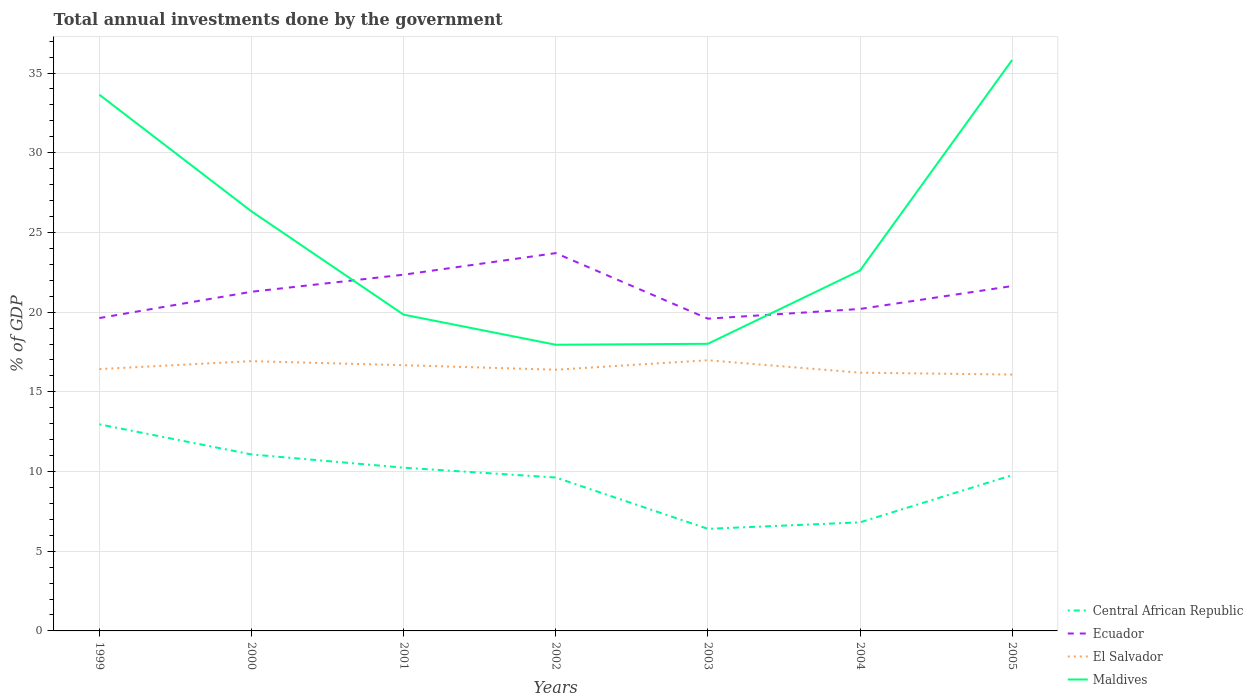Across all years, what is the maximum total annual investments done by the government in Ecuador?
Provide a succinct answer. 19.59. In which year was the total annual investments done by the government in El Salvador maximum?
Your answer should be very brief. 2005. What is the total total annual investments done by the government in Maldives in the graph?
Give a very brief answer. 6.48. What is the difference between the highest and the second highest total annual investments done by the government in Central African Republic?
Your answer should be compact. 6.56. Is the total annual investments done by the government in Ecuador strictly greater than the total annual investments done by the government in Maldives over the years?
Your answer should be compact. No. How many years are there in the graph?
Ensure brevity in your answer.  7. Are the values on the major ticks of Y-axis written in scientific E-notation?
Your answer should be very brief. No. How many legend labels are there?
Keep it short and to the point. 4. What is the title of the graph?
Keep it short and to the point. Total annual investments done by the government. Does "Syrian Arab Republic" appear as one of the legend labels in the graph?
Your answer should be very brief. No. What is the label or title of the X-axis?
Keep it short and to the point. Years. What is the label or title of the Y-axis?
Offer a terse response. % of GDP. What is the % of GDP in Central African Republic in 1999?
Make the answer very short. 12.96. What is the % of GDP in Ecuador in 1999?
Give a very brief answer. 19.63. What is the % of GDP in El Salvador in 1999?
Make the answer very short. 16.43. What is the % of GDP of Maldives in 1999?
Provide a short and direct response. 33.64. What is the % of GDP in Central African Republic in 2000?
Make the answer very short. 11.07. What is the % of GDP of Ecuador in 2000?
Your answer should be compact. 21.28. What is the % of GDP of El Salvador in 2000?
Provide a succinct answer. 16.93. What is the % of GDP of Maldives in 2000?
Make the answer very short. 26.32. What is the % of GDP of Central African Republic in 2001?
Keep it short and to the point. 10.24. What is the % of GDP in Ecuador in 2001?
Make the answer very short. 22.35. What is the % of GDP in El Salvador in 2001?
Offer a very short reply. 16.67. What is the % of GDP of Maldives in 2001?
Keep it short and to the point. 19.84. What is the % of GDP in Central African Republic in 2002?
Provide a succinct answer. 9.62. What is the % of GDP of Ecuador in 2002?
Offer a terse response. 23.7. What is the % of GDP of El Salvador in 2002?
Your response must be concise. 16.39. What is the % of GDP of Maldives in 2002?
Offer a terse response. 17.95. What is the % of GDP of Central African Republic in 2003?
Make the answer very short. 6.4. What is the % of GDP of Ecuador in 2003?
Ensure brevity in your answer.  19.59. What is the % of GDP of El Salvador in 2003?
Provide a succinct answer. 16.98. What is the % of GDP of Maldives in 2003?
Ensure brevity in your answer.  18.01. What is the % of GDP of Central African Republic in 2004?
Make the answer very short. 6.81. What is the % of GDP of Ecuador in 2004?
Give a very brief answer. 20.2. What is the % of GDP of El Salvador in 2004?
Offer a terse response. 16.2. What is the % of GDP of Maldives in 2004?
Your answer should be very brief. 22.61. What is the % of GDP of Central African Republic in 2005?
Offer a very short reply. 9.77. What is the % of GDP in Ecuador in 2005?
Keep it short and to the point. 21.64. What is the % of GDP in El Salvador in 2005?
Offer a terse response. 16.08. What is the % of GDP in Maldives in 2005?
Your answer should be compact. 35.82. Across all years, what is the maximum % of GDP of Central African Republic?
Provide a succinct answer. 12.96. Across all years, what is the maximum % of GDP of Ecuador?
Offer a very short reply. 23.7. Across all years, what is the maximum % of GDP of El Salvador?
Make the answer very short. 16.98. Across all years, what is the maximum % of GDP in Maldives?
Your answer should be compact. 35.82. Across all years, what is the minimum % of GDP of Central African Republic?
Your answer should be very brief. 6.4. Across all years, what is the minimum % of GDP in Ecuador?
Your answer should be very brief. 19.59. Across all years, what is the minimum % of GDP of El Salvador?
Keep it short and to the point. 16.08. Across all years, what is the minimum % of GDP of Maldives?
Provide a succinct answer. 17.95. What is the total % of GDP of Central African Republic in the graph?
Provide a short and direct response. 66.89. What is the total % of GDP of Ecuador in the graph?
Provide a short and direct response. 148.38. What is the total % of GDP in El Salvador in the graph?
Provide a short and direct response. 115.68. What is the total % of GDP of Maldives in the graph?
Give a very brief answer. 174.2. What is the difference between the % of GDP of Central African Republic in 1999 and that in 2000?
Offer a very short reply. 1.89. What is the difference between the % of GDP in Ecuador in 1999 and that in 2000?
Keep it short and to the point. -1.65. What is the difference between the % of GDP in El Salvador in 1999 and that in 2000?
Ensure brevity in your answer.  -0.5. What is the difference between the % of GDP in Maldives in 1999 and that in 2000?
Provide a short and direct response. 7.32. What is the difference between the % of GDP of Central African Republic in 1999 and that in 2001?
Make the answer very short. 2.72. What is the difference between the % of GDP of Ecuador in 1999 and that in 2001?
Offer a terse response. -2.72. What is the difference between the % of GDP in El Salvador in 1999 and that in 2001?
Provide a succinct answer. -0.24. What is the difference between the % of GDP in Maldives in 1999 and that in 2001?
Your answer should be very brief. 13.8. What is the difference between the % of GDP in Central African Republic in 1999 and that in 2002?
Provide a succinct answer. 3.34. What is the difference between the % of GDP in Ecuador in 1999 and that in 2002?
Provide a succinct answer. -4.07. What is the difference between the % of GDP in El Salvador in 1999 and that in 2002?
Keep it short and to the point. 0.04. What is the difference between the % of GDP in Maldives in 1999 and that in 2002?
Offer a very short reply. 15.68. What is the difference between the % of GDP of Central African Republic in 1999 and that in 2003?
Provide a short and direct response. 6.56. What is the difference between the % of GDP of Ecuador in 1999 and that in 2003?
Give a very brief answer. 0.04. What is the difference between the % of GDP in El Salvador in 1999 and that in 2003?
Provide a succinct answer. -0.55. What is the difference between the % of GDP in Maldives in 1999 and that in 2003?
Your response must be concise. 15.63. What is the difference between the % of GDP of Central African Republic in 1999 and that in 2004?
Your answer should be very brief. 6.15. What is the difference between the % of GDP of Ecuador in 1999 and that in 2004?
Give a very brief answer. -0.57. What is the difference between the % of GDP of El Salvador in 1999 and that in 2004?
Offer a very short reply. 0.22. What is the difference between the % of GDP of Maldives in 1999 and that in 2004?
Offer a terse response. 11.03. What is the difference between the % of GDP in Central African Republic in 1999 and that in 2005?
Provide a short and direct response. 3.19. What is the difference between the % of GDP in Ecuador in 1999 and that in 2005?
Make the answer very short. -2.01. What is the difference between the % of GDP of El Salvador in 1999 and that in 2005?
Provide a short and direct response. 0.34. What is the difference between the % of GDP in Maldives in 1999 and that in 2005?
Provide a succinct answer. -2.18. What is the difference between the % of GDP of Central African Republic in 2000 and that in 2001?
Make the answer very short. 0.83. What is the difference between the % of GDP of Ecuador in 2000 and that in 2001?
Ensure brevity in your answer.  -1.07. What is the difference between the % of GDP of El Salvador in 2000 and that in 2001?
Keep it short and to the point. 0.26. What is the difference between the % of GDP in Maldives in 2000 and that in 2001?
Keep it short and to the point. 6.48. What is the difference between the % of GDP of Central African Republic in 2000 and that in 2002?
Make the answer very short. 1.45. What is the difference between the % of GDP in Ecuador in 2000 and that in 2002?
Provide a succinct answer. -2.42. What is the difference between the % of GDP in El Salvador in 2000 and that in 2002?
Offer a terse response. 0.54. What is the difference between the % of GDP in Maldives in 2000 and that in 2002?
Your response must be concise. 8.37. What is the difference between the % of GDP in Central African Republic in 2000 and that in 2003?
Your answer should be very brief. 4.67. What is the difference between the % of GDP in Ecuador in 2000 and that in 2003?
Ensure brevity in your answer.  1.69. What is the difference between the % of GDP in El Salvador in 2000 and that in 2003?
Keep it short and to the point. -0.06. What is the difference between the % of GDP of Maldives in 2000 and that in 2003?
Offer a terse response. 8.31. What is the difference between the % of GDP in Central African Republic in 2000 and that in 2004?
Provide a succinct answer. 4.26. What is the difference between the % of GDP of Ecuador in 2000 and that in 2004?
Give a very brief answer. 1.08. What is the difference between the % of GDP in El Salvador in 2000 and that in 2004?
Offer a very short reply. 0.72. What is the difference between the % of GDP of Maldives in 2000 and that in 2004?
Keep it short and to the point. 3.71. What is the difference between the % of GDP in Central African Republic in 2000 and that in 2005?
Make the answer very short. 1.3. What is the difference between the % of GDP of Ecuador in 2000 and that in 2005?
Ensure brevity in your answer.  -0.36. What is the difference between the % of GDP of El Salvador in 2000 and that in 2005?
Offer a very short reply. 0.84. What is the difference between the % of GDP in Maldives in 2000 and that in 2005?
Keep it short and to the point. -9.49. What is the difference between the % of GDP in Central African Republic in 2001 and that in 2002?
Keep it short and to the point. 0.62. What is the difference between the % of GDP in Ecuador in 2001 and that in 2002?
Ensure brevity in your answer.  -1.35. What is the difference between the % of GDP of El Salvador in 2001 and that in 2002?
Offer a very short reply. 0.28. What is the difference between the % of GDP of Maldives in 2001 and that in 2002?
Provide a short and direct response. 1.89. What is the difference between the % of GDP of Central African Republic in 2001 and that in 2003?
Your answer should be very brief. 3.84. What is the difference between the % of GDP in Ecuador in 2001 and that in 2003?
Make the answer very short. 2.76. What is the difference between the % of GDP of El Salvador in 2001 and that in 2003?
Provide a succinct answer. -0.31. What is the difference between the % of GDP of Maldives in 2001 and that in 2003?
Provide a short and direct response. 1.83. What is the difference between the % of GDP of Central African Republic in 2001 and that in 2004?
Offer a very short reply. 3.43. What is the difference between the % of GDP of Ecuador in 2001 and that in 2004?
Provide a short and direct response. 2.15. What is the difference between the % of GDP of El Salvador in 2001 and that in 2004?
Your response must be concise. 0.47. What is the difference between the % of GDP of Maldives in 2001 and that in 2004?
Your response must be concise. -2.77. What is the difference between the % of GDP in Central African Republic in 2001 and that in 2005?
Give a very brief answer. 0.47. What is the difference between the % of GDP in Ecuador in 2001 and that in 2005?
Offer a very short reply. 0.71. What is the difference between the % of GDP of El Salvador in 2001 and that in 2005?
Offer a very short reply. 0.59. What is the difference between the % of GDP of Maldives in 2001 and that in 2005?
Provide a short and direct response. -15.97. What is the difference between the % of GDP in Central African Republic in 2002 and that in 2003?
Make the answer very short. 3.22. What is the difference between the % of GDP of Ecuador in 2002 and that in 2003?
Give a very brief answer. 4.11. What is the difference between the % of GDP of El Salvador in 2002 and that in 2003?
Offer a terse response. -0.59. What is the difference between the % of GDP in Maldives in 2002 and that in 2003?
Your answer should be very brief. -0.06. What is the difference between the % of GDP in Central African Republic in 2002 and that in 2004?
Offer a very short reply. 2.81. What is the difference between the % of GDP of Ecuador in 2002 and that in 2004?
Offer a terse response. 3.5. What is the difference between the % of GDP in El Salvador in 2002 and that in 2004?
Your response must be concise. 0.19. What is the difference between the % of GDP in Maldives in 2002 and that in 2004?
Keep it short and to the point. -4.66. What is the difference between the % of GDP in Central African Republic in 2002 and that in 2005?
Keep it short and to the point. -0.15. What is the difference between the % of GDP in Ecuador in 2002 and that in 2005?
Your answer should be very brief. 2.07. What is the difference between the % of GDP in El Salvador in 2002 and that in 2005?
Give a very brief answer. 0.3. What is the difference between the % of GDP in Maldives in 2002 and that in 2005?
Your answer should be very brief. -17.86. What is the difference between the % of GDP of Central African Republic in 2003 and that in 2004?
Provide a short and direct response. -0.41. What is the difference between the % of GDP of Ecuador in 2003 and that in 2004?
Offer a terse response. -0.61. What is the difference between the % of GDP of El Salvador in 2003 and that in 2004?
Make the answer very short. 0.78. What is the difference between the % of GDP of Maldives in 2003 and that in 2004?
Your answer should be compact. -4.6. What is the difference between the % of GDP of Central African Republic in 2003 and that in 2005?
Provide a succinct answer. -3.37. What is the difference between the % of GDP of Ecuador in 2003 and that in 2005?
Offer a terse response. -2.05. What is the difference between the % of GDP in El Salvador in 2003 and that in 2005?
Ensure brevity in your answer.  0.9. What is the difference between the % of GDP in Maldives in 2003 and that in 2005?
Offer a very short reply. -17.8. What is the difference between the % of GDP of Central African Republic in 2004 and that in 2005?
Provide a short and direct response. -2.96. What is the difference between the % of GDP in Ecuador in 2004 and that in 2005?
Your answer should be very brief. -1.44. What is the difference between the % of GDP of El Salvador in 2004 and that in 2005?
Your response must be concise. 0.12. What is the difference between the % of GDP of Maldives in 2004 and that in 2005?
Keep it short and to the point. -13.21. What is the difference between the % of GDP of Central African Republic in 1999 and the % of GDP of Ecuador in 2000?
Provide a succinct answer. -8.32. What is the difference between the % of GDP in Central African Republic in 1999 and the % of GDP in El Salvador in 2000?
Offer a terse response. -3.96. What is the difference between the % of GDP of Central African Republic in 1999 and the % of GDP of Maldives in 2000?
Offer a terse response. -13.36. What is the difference between the % of GDP in Ecuador in 1999 and the % of GDP in El Salvador in 2000?
Keep it short and to the point. 2.7. What is the difference between the % of GDP of Ecuador in 1999 and the % of GDP of Maldives in 2000?
Provide a succinct answer. -6.69. What is the difference between the % of GDP in El Salvador in 1999 and the % of GDP in Maldives in 2000?
Provide a succinct answer. -9.9. What is the difference between the % of GDP of Central African Republic in 1999 and the % of GDP of Ecuador in 2001?
Ensure brevity in your answer.  -9.39. What is the difference between the % of GDP in Central African Republic in 1999 and the % of GDP in El Salvador in 2001?
Provide a short and direct response. -3.71. What is the difference between the % of GDP of Central African Republic in 1999 and the % of GDP of Maldives in 2001?
Your answer should be compact. -6.88. What is the difference between the % of GDP in Ecuador in 1999 and the % of GDP in El Salvador in 2001?
Provide a short and direct response. 2.96. What is the difference between the % of GDP of Ecuador in 1999 and the % of GDP of Maldives in 2001?
Keep it short and to the point. -0.21. What is the difference between the % of GDP in El Salvador in 1999 and the % of GDP in Maldives in 2001?
Ensure brevity in your answer.  -3.42. What is the difference between the % of GDP of Central African Republic in 1999 and the % of GDP of Ecuador in 2002?
Keep it short and to the point. -10.74. What is the difference between the % of GDP of Central African Republic in 1999 and the % of GDP of El Salvador in 2002?
Make the answer very short. -3.43. What is the difference between the % of GDP in Central African Republic in 1999 and the % of GDP in Maldives in 2002?
Give a very brief answer. -4.99. What is the difference between the % of GDP of Ecuador in 1999 and the % of GDP of El Salvador in 2002?
Ensure brevity in your answer.  3.24. What is the difference between the % of GDP in Ecuador in 1999 and the % of GDP in Maldives in 2002?
Ensure brevity in your answer.  1.67. What is the difference between the % of GDP in El Salvador in 1999 and the % of GDP in Maldives in 2002?
Provide a short and direct response. -1.53. What is the difference between the % of GDP in Central African Republic in 1999 and the % of GDP in Ecuador in 2003?
Keep it short and to the point. -6.63. What is the difference between the % of GDP of Central African Republic in 1999 and the % of GDP of El Salvador in 2003?
Provide a succinct answer. -4.02. What is the difference between the % of GDP of Central African Republic in 1999 and the % of GDP of Maldives in 2003?
Offer a terse response. -5.05. What is the difference between the % of GDP in Ecuador in 1999 and the % of GDP in El Salvador in 2003?
Give a very brief answer. 2.65. What is the difference between the % of GDP of Ecuador in 1999 and the % of GDP of Maldives in 2003?
Offer a terse response. 1.61. What is the difference between the % of GDP in El Salvador in 1999 and the % of GDP in Maldives in 2003?
Your answer should be very brief. -1.59. What is the difference between the % of GDP of Central African Republic in 1999 and the % of GDP of Ecuador in 2004?
Your answer should be very brief. -7.24. What is the difference between the % of GDP of Central African Republic in 1999 and the % of GDP of El Salvador in 2004?
Give a very brief answer. -3.24. What is the difference between the % of GDP of Central African Republic in 1999 and the % of GDP of Maldives in 2004?
Offer a terse response. -9.65. What is the difference between the % of GDP in Ecuador in 1999 and the % of GDP in El Salvador in 2004?
Your answer should be compact. 3.43. What is the difference between the % of GDP of Ecuador in 1999 and the % of GDP of Maldives in 2004?
Your response must be concise. -2.98. What is the difference between the % of GDP in El Salvador in 1999 and the % of GDP in Maldives in 2004?
Offer a very short reply. -6.18. What is the difference between the % of GDP in Central African Republic in 1999 and the % of GDP in Ecuador in 2005?
Offer a terse response. -8.68. What is the difference between the % of GDP of Central African Republic in 1999 and the % of GDP of El Salvador in 2005?
Keep it short and to the point. -3.12. What is the difference between the % of GDP of Central African Republic in 1999 and the % of GDP of Maldives in 2005?
Provide a succinct answer. -22.86. What is the difference between the % of GDP in Ecuador in 1999 and the % of GDP in El Salvador in 2005?
Your answer should be very brief. 3.55. What is the difference between the % of GDP of Ecuador in 1999 and the % of GDP of Maldives in 2005?
Keep it short and to the point. -16.19. What is the difference between the % of GDP of El Salvador in 1999 and the % of GDP of Maldives in 2005?
Ensure brevity in your answer.  -19.39. What is the difference between the % of GDP of Central African Republic in 2000 and the % of GDP of Ecuador in 2001?
Offer a very short reply. -11.28. What is the difference between the % of GDP in Central African Republic in 2000 and the % of GDP in El Salvador in 2001?
Keep it short and to the point. -5.6. What is the difference between the % of GDP of Central African Republic in 2000 and the % of GDP of Maldives in 2001?
Give a very brief answer. -8.77. What is the difference between the % of GDP in Ecuador in 2000 and the % of GDP in El Salvador in 2001?
Give a very brief answer. 4.61. What is the difference between the % of GDP of Ecuador in 2000 and the % of GDP of Maldives in 2001?
Keep it short and to the point. 1.44. What is the difference between the % of GDP in El Salvador in 2000 and the % of GDP in Maldives in 2001?
Your answer should be compact. -2.92. What is the difference between the % of GDP of Central African Republic in 2000 and the % of GDP of Ecuador in 2002?
Your answer should be compact. -12.63. What is the difference between the % of GDP of Central African Republic in 2000 and the % of GDP of El Salvador in 2002?
Your response must be concise. -5.32. What is the difference between the % of GDP in Central African Republic in 2000 and the % of GDP in Maldives in 2002?
Make the answer very short. -6.88. What is the difference between the % of GDP in Ecuador in 2000 and the % of GDP in El Salvador in 2002?
Provide a succinct answer. 4.89. What is the difference between the % of GDP of Ecuador in 2000 and the % of GDP of Maldives in 2002?
Keep it short and to the point. 3.32. What is the difference between the % of GDP of El Salvador in 2000 and the % of GDP of Maldives in 2002?
Your response must be concise. -1.03. What is the difference between the % of GDP of Central African Republic in 2000 and the % of GDP of Ecuador in 2003?
Provide a succinct answer. -8.52. What is the difference between the % of GDP of Central African Republic in 2000 and the % of GDP of El Salvador in 2003?
Offer a terse response. -5.91. What is the difference between the % of GDP in Central African Republic in 2000 and the % of GDP in Maldives in 2003?
Offer a terse response. -6.94. What is the difference between the % of GDP in Ecuador in 2000 and the % of GDP in El Salvador in 2003?
Offer a terse response. 4.3. What is the difference between the % of GDP of Ecuador in 2000 and the % of GDP of Maldives in 2003?
Give a very brief answer. 3.26. What is the difference between the % of GDP of El Salvador in 2000 and the % of GDP of Maldives in 2003?
Provide a short and direct response. -1.09. What is the difference between the % of GDP in Central African Republic in 2000 and the % of GDP in Ecuador in 2004?
Ensure brevity in your answer.  -9.13. What is the difference between the % of GDP in Central African Republic in 2000 and the % of GDP in El Salvador in 2004?
Offer a terse response. -5.13. What is the difference between the % of GDP in Central African Republic in 2000 and the % of GDP in Maldives in 2004?
Give a very brief answer. -11.54. What is the difference between the % of GDP in Ecuador in 2000 and the % of GDP in El Salvador in 2004?
Your answer should be very brief. 5.08. What is the difference between the % of GDP in Ecuador in 2000 and the % of GDP in Maldives in 2004?
Offer a very short reply. -1.33. What is the difference between the % of GDP of El Salvador in 2000 and the % of GDP of Maldives in 2004?
Your answer should be compact. -5.68. What is the difference between the % of GDP in Central African Republic in 2000 and the % of GDP in Ecuador in 2005?
Keep it short and to the point. -10.56. What is the difference between the % of GDP of Central African Republic in 2000 and the % of GDP of El Salvador in 2005?
Keep it short and to the point. -5.01. What is the difference between the % of GDP of Central African Republic in 2000 and the % of GDP of Maldives in 2005?
Ensure brevity in your answer.  -24.75. What is the difference between the % of GDP of Ecuador in 2000 and the % of GDP of El Salvador in 2005?
Offer a very short reply. 5.2. What is the difference between the % of GDP in Ecuador in 2000 and the % of GDP in Maldives in 2005?
Offer a terse response. -14.54. What is the difference between the % of GDP of El Salvador in 2000 and the % of GDP of Maldives in 2005?
Keep it short and to the point. -18.89. What is the difference between the % of GDP in Central African Republic in 2001 and the % of GDP in Ecuador in 2002?
Make the answer very short. -13.46. What is the difference between the % of GDP of Central African Republic in 2001 and the % of GDP of El Salvador in 2002?
Keep it short and to the point. -6.15. What is the difference between the % of GDP in Central African Republic in 2001 and the % of GDP in Maldives in 2002?
Make the answer very short. -7.71. What is the difference between the % of GDP in Ecuador in 2001 and the % of GDP in El Salvador in 2002?
Offer a very short reply. 5.96. What is the difference between the % of GDP of Ecuador in 2001 and the % of GDP of Maldives in 2002?
Your answer should be very brief. 4.39. What is the difference between the % of GDP in El Salvador in 2001 and the % of GDP in Maldives in 2002?
Make the answer very short. -1.28. What is the difference between the % of GDP in Central African Republic in 2001 and the % of GDP in Ecuador in 2003?
Provide a succinct answer. -9.35. What is the difference between the % of GDP in Central African Republic in 2001 and the % of GDP in El Salvador in 2003?
Ensure brevity in your answer.  -6.74. What is the difference between the % of GDP in Central African Republic in 2001 and the % of GDP in Maldives in 2003?
Provide a short and direct response. -7.77. What is the difference between the % of GDP in Ecuador in 2001 and the % of GDP in El Salvador in 2003?
Make the answer very short. 5.37. What is the difference between the % of GDP in Ecuador in 2001 and the % of GDP in Maldives in 2003?
Provide a short and direct response. 4.34. What is the difference between the % of GDP of El Salvador in 2001 and the % of GDP of Maldives in 2003?
Give a very brief answer. -1.34. What is the difference between the % of GDP of Central African Republic in 2001 and the % of GDP of Ecuador in 2004?
Ensure brevity in your answer.  -9.96. What is the difference between the % of GDP in Central African Republic in 2001 and the % of GDP in El Salvador in 2004?
Give a very brief answer. -5.96. What is the difference between the % of GDP of Central African Republic in 2001 and the % of GDP of Maldives in 2004?
Offer a very short reply. -12.37. What is the difference between the % of GDP in Ecuador in 2001 and the % of GDP in El Salvador in 2004?
Provide a succinct answer. 6.15. What is the difference between the % of GDP in Ecuador in 2001 and the % of GDP in Maldives in 2004?
Your answer should be compact. -0.26. What is the difference between the % of GDP in El Salvador in 2001 and the % of GDP in Maldives in 2004?
Your response must be concise. -5.94. What is the difference between the % of GDP in Central African Republic in 2001 and the % of GDP in Ecuador in 2005?
Your answer should be compact. -11.4. What is the difference between the % of GDP in Central African Republic in 2001 and the % of GDP in El Salvador in 2005?
Your answer should be very brief. -5.84. What is the difference between the % of GDP of Central African Republic in 2001 and the % of GDP of Maldives in 2005?
Your answer should be very brief. -25.58. What is the difference between the % of GDP in Ecuador in 2001 and the % of GDP in El Salvador in 2005?
Your answer should be very brief. 6.27. What is the difference between the % of GDP of Ecuador in 2001 and the % of GDP of Maldives in 2005?
Give a very brief answer. -13.47. What is the difference between the % of GDP in El Salvador in 2001 and the % of GDP in Maldives in 2005?
Make the answer very short. -19.15. What is the difference between the % of GDP of Central African Republic in 2002 and the % of GDP of Ecuador in 2003?
Provide a short and direct response. -9.96. What is the difference between the % of GDP of Central African Republic in 2002 and the % of GDP of El Salvador in 2003?
Keep it short and to the point. -7.36. What is the difference between the % of GDP of Central African Republic in 2002 and the % of GDP of Maldives in 2003?
Keep it short and to the point. -8.39. What is the difference between the % of GDP of Ecuador in 2002 and the % of GDP of El Salvador in 2003?
Provide a short and direct response. 6.72. What is the difference between the % of GDP in Ecuador in 2002 and the % of GDP in Maldives in 2003?
Provide a short and direct response. 5.69. What is the difference between the % of GDP in El Salvador in 2002 and the % of GDP in Maldives in 2003?
Provide a short and direct response. -1.63. What is the difference between the % of GDP in Central African Republic in 2002 and the % of GDP in Ecuador in 2004?
Make the answer very short. -10.57. What is the difference between the % of GDP in Central African Republic in 2002 and the % of GDP in El Salvador in 2004?
Offer a terse response. -6.58. What is the difference between the % of GDP in Central African Republic in 2002 and the % of GDP in Maldives in 2004?
Keep it short and to the point. -12.99. What is the difference between the % of GDP of Ecuador in 2002 and the % of GDP of Maldives in 2004?
Offer a very short reply. 1.09. What is the difference between the % of GDP in El Salvador in 2002 and the % of GDP in Maldives in 2004?
Keep it short and to the point. -6.22. What is the difference between the % of GDP of Central African Republic in 2002 and the % of GDP of Ecuador in 2005?
Make the answer very short. -12.01. What is the difference between the % of GDP of Central African Republic in 2002 and the % of GDP of El Salvador in 2005?
Your answer should be very brief. -6.46. What is the difference between the % of GDP in Central African Republic in 2002 and the % of GDP in Maldives in 2005?
Your answer should be very brief. -26.19. What is the difference between the % of GDP in Ecuador in 2002 and the % of GDP in El Salvador in 2005?
Offer a terse response. 7.62. What is the difference between the % of GDP in Ecuador in 2002 and the % of GDP in Maldives in 2005?
Your response must be concise. -12.12. What is the difference between the % of GDP in El Salvador in 2002 and the % of GDP in Maldives in 2005?
Ensure brevity in your answer.  -19.43. What is the difference between the % of GDP in Central African Republic in 2003 and the % of GDP in Ecuador in 2004?
Ensure brevity in your answer.  -13.79. What is the difference between the % of GDP in Central African Republic in 2003 and the % of GDP in El Salvador in 2004?
Your answer should be compact. -9.8. What is the difference between the % of GDP in Central African Republic in 2003 and the % of GDP in Maldives in 2004?
Offer a terse response. -16.21. What is the difference between the % of GDP in Ecuador in 2003 and the % of GDP in El Salvador in 2004?
Provide a short and direct response. 3.39. What is the difference between the % of GDP of Ecuador in 2003 and the % of GDP of Maldives in 2004?
Offer a terse response. -3.02. What is the difference between the % of GDP in El Salvador in 2003 and the % of GDP in Maldives in 2004?
Your answer should be compact. -5.63. What is the difference between the % of GDP in Central African Republic in 2003 and the % of GDP in Ecuador in 2005?
Offer a very short reply. -15.23. What is the difference between the % of GDP in Central African Republic in 2003 and the % of GDP in El Salvador in 2005?
Ensure brevity in your answer.  -9.68. What is the difference between the % of GDP of Central African Republic in 2003 and the % of GDP of Maldives in 2005?
Offer a terse response. -29.41. What is the difference between the % of GDP in Ecuador in 2003 and the % of GDP in El Salvador in 2005?
Your answer should be compact. 3.51. What is the difference between the % of GDP of Ecuador in 2003 and the % of GDP of Maldives in 2005?
Keep it short and to the point. -16.23. What is the difference between the % of GDP in El Salvador in 2003 and the % of GDP in Maldives in 2005?
Give a very brief answer. -18.84. What is the difference between the % of GDP in Central African Republic in 2004 and the % of GDP in Ecuador in 2005?
Your answer should be very brief. -14.82. What is the difference between the % of GDP of Central African Republic in 2004 and the % of GDP of El Salvador in 2005?
Your answer should be very brief. -9.27. What is the difference between the % of GDP in Central African Republic in 2004 and the % of GDP in Maldives in 2005?
Give a very brief answer. -29.01. What is the difference between the % of GDP of Ecuador in 2004 and the % of GDP of El Salvador in 2005?
Make the answer very short. 4.12. What is the difference between the % of GDP in Ecuador in 2004 and the % of GDP in Maldives in 2005?
Ensure brevity in your answer.  -15.62. What is the difference between the % of GDP of El Salvador in 2004 and the % of GDP of Maldives in 2005?
Provide a succinct answer. -19.62. What is the average % of GDP in Central African Republic per year?
Make the answer very short. 9.56. What is the average % of GDP of Ecuador per year?
Provide a succinct answer. 21.2. What is the average % of GDP in El Salvador per year?
Offer a very short reply. 16.53. What is the average % of GDP in Maldives per year?
Your answer should be very brief. 24.89. In the year 1999, what is the difference between the % of GDP of Central African Republic and % of GDP of Ecuador?
Provide a succinct answer. -6.67. In the year 1999, what is the difference between the % of GDP of Central African Republic and % of GDP of El Salvador?
Ensure brevity in your answer.  -3.46. In the year 1999, what is the difference between the % of GDP in Central African Republic and % of GDP in Maldives?
Make the answer very short. -20.68. In the year 1999, what is the difference between the % of GDP of Ecuador and % of GDP of El Salvador?
Give a very brief answer. 3.2. In the year 1999, what is the difference between the % of GDP of Ecuador and % of GDP of Maldives?
Give a very brief answer. -14.01. In the year 1999, what is the difference between the % of GDP of El Salvador and % of GDP of Maldives?
Offer a terse response. -17.21. In the year 2000, what is the difference between the % of GDP of Central African Republic and % of GDP of Ecuador?
Your answer should be compact. -10.21. In the year 2000, what is the difference between the % of GDP of Central African Republic and % of GDP of El Salvador?
Your answer should be very brief. -5.85. In the year 2000, what is the difference between the % of GDP in Central African Republic and % of GDP in Maldives?
Your response must be concise. -15.25. In the year 2000, what is the difference between the % of GDP in Ecuador and % of GDP in El Salvador?
Offer a very short reply. 4.35. In the year 2000, what is the difference between the % of GDP in Ecuador and % of GDP in Maldives?
Offer a terse response. -5.04. In the year 2000, what is the difference between the % of GDP of El Salvador and % of GDP of Maldives?
Keep it short and to the point. -9.4. In the year 2001, what is the difference between the % of GDP in Central African Republic and % of GDP in Ecuador?
Provide a succinct answer. -12.11. In the year 2001, what is the difference between the % of GDP in Central African Republic and % of GDP in El Salvador?
Keep it short and to the point. -6.43. In the year 2001, what is the difference between the % of GDP in Central African Republic and % of GDP in Maldives?
Ensure brevity in your answer.  -9.6. In the year 2001, what is the difference between the % of GDP of Ecuador and % of GDP of El Salvador?
Make the answer very short. 5.68. In the year 2001, what is the difference between the % of GDP of Ecuador and % of GDP of Maldives?
Your response must be concise. 2.51. In the year 2001, what is the difference between the % of GDP of El Salvador and % of GDP of Maldives?
Provide a succinct answer. -3.17. In the year 2002, what is the difference between the % of GDP in Central African Republic and % of GDP in Ecuador?
Your answer should be compact. -14.08. In the year 2002, what is the difference between the % of GDP of Central African Republic and % of GDP of El Salvador?
Make the answer very short. -6.76. In the year 2002, what is the difference between the % of GDP in Central African Republic and % of GDP in Maldives?
Give a very brief answer. -8.33. In the year 2002, what is the difference between the % of GDP of Ecuador and % of GDP of El Salvador?
Offer a very short reply. 7.32. In the year 2002, what is the difference between the % of GDP of Ecuador and % of GDP of Maldives?
Offer a terse response. 5.75. In the year 2002, what is the difference between the % of GDP in El Salvador and % of GDP in Maldives?
Your response must be concise. -1.57. In the year 2003, what is the difference between the % of GDP in Central African Republic and % of GDP in Ecuador?
Provide a succinct answer. -13.18. In the year 2003, what is the difference between the % of GDP in Central African Republic and % of GDP in El Salvador?
Make the answer very short. -10.58. In the year 2003, what is the difference between the % of GDP of Central African Republic and % of GDP of Maldives?
Offer a very short reply. -11.61. In the year 2003, what is the difference between the % of GDP of Ecuador and % of GDP of El Salvador?
Offer a terse response. 2.61. In the year 2003, what is the difference between the % of GDP of Ecuador and % of GDP of Maldives?
Provide a succinct answer. 1.58. In the year 2003, what is the difference between the % of GDP in El Salvador and % of GDP in Maldives?
Ensure brevity in your answer.  -1.03. In the year 2004, what is the difference between the % of GDP of Central African Republic and % of GDP of Ecuador?
Your answer should be compact. -13.39. In the year 2004, what is the difference between the % of GDP in Central African Republic and % of GDP in El Salvador?
Offer a very short reply. -9.39. In the year 2004, what is the difference between the % of GDP in Central African Republic and % of GDP in Maldives?
Give a very brief answer. -15.8. In the year 2004, what is the difference between the % of GDP in Ecuador and % of GDP in El Salvador?
Your answer should be very brief. 4. In the year 2004, what is the difference between the % of GDP in Ecuador and % of GDP in Maldives?
Your answer should be compact. -2.41. In the year 2004, what is the difference between the % of GDP in El Salvador and % of GDP in Maldives?
Make the answer very short. -6.41. In the year 2005, what is the difference between the % of GDP of Central African Republic and % of GDP of Ecuador?
Provide a short and direct response. -11.87. In the year 2005, what is the difference between the % of GDP of Central African Republic and % of GDP of El Salvador?
Offer a very short reply. -6.31. In the year 2005, what is the difference between the % of GDP in Central African Republic and % of GDP in Maldives?
Keep it short and to the point. -26.05. In the year 2005, what is the difference between the % of GDP of Ecuador and % of GDP of El Salvador?
Your response must be concise. 5.55. In the year 2005, what is the difference between the % of GDP of Ecuador and % of GDP of Maldives?
Give a very brief answer. -14.18. In the year 2005, what is the difference between the % of GDP of El Salvador and % of GDP of Maldives?
Offer a very short reply. -19.73. What is the ratio of the % of GDP of Central African Republic in 1999 to that in 2000?
Your response must be concise. 1.17. What is the ratio of the % of GDP of Ecuador in 1999 to that in 2000?
Your answer should be very brief. 0.92. What is the ratio of the % of GDP in El Salvador in 1999 to that in 2000?
Offer a very short reply. 0.97. What is the ratio of the % of GDP of Maldives in 1999 to that in 2000?
Make the answer very short. 1.28. What is the ratio of the % of GDP of Central African Republic in 1999 to that in 2001?
Give a very brief answer. 1.27. What is the ratio of the % of GDP of Ecuador in 1999 to that in 2001?
Make the answer very short. 0.88. What is the ratio of the % of GDP of El Salvador in 1999 to that in 2001?
Give a very brief answer. 0.99. What is the ratio of the % of GDP in Maldives in 1999 to that in 2001?
Your answer should be very brief. 1.7. What is the ratio of the % of GDP of Central African Republic in 1999 to that in 2002?
Your answer should be compact. 1.35. What is the ratio of the % of GDP of Ecuador in 1999 to that in 2002?
Provide a succinct answer. 0.83. What is the ratio of the % of GDP of Maldives in 1999 to that in 2002?
Offer a terse response. 1.87. What is the ratio of the % of GDP in Central African Republic in 1999 to that in 2003?
Provide a succinct answer. 2.02. What is the ratio of the % of GDP of Ecuador in 1999 to that in 2003?
Provide a succinct answer. 1. What is the ratio of the % of GDP in El Salvador in 1999 to that in 2003?
Keep it short and to the point. 0.97. What is the ratio of the % of GDP in Maldives in 1999 to that in 2003?
Your answer should be compact. 1.87. What is the ratio of the % of GDP in Central African Republic in 1999 to that in 2004?
Your response must be concise. 1.9. What is the ratio of the % of GDP of Ecuador in 1999 to that in 2004?
Keep it short and to the point. 0.97. What is the ratio of the % of GDP in El Salvador in 1999 to that in 2004?
Give a very brief answer. 1.01. What is the ratio of the % of GDP in Maldives in 1999 to that in 2004?
Your answer should be compact. 1.49. What is the ratio of the % of GDP in Central African Republic in 1999 to that in 2005?
Make the answer very short. 1.33. What is the ratio of the % of GDP in Ecuador in 1999 to that in 2005?
Give a very brief answer. 0.91. What is the ratio of the % of GDP in El Salvador in 1999 to that in 2005?
Keep it short and to the point. 1.02. What is the ratio of the % of GDP of Maldives in 1999 to that in 2005?
Keep it short and to the point. 0.94. What is the ratio of the % of GDP in Central African Republic in 2000 to that in 2001?
Your response must be concise. 1.08. What is the ratio of the % of GDP of Ecuador in 2000 to that in 2001?
Give a very brief answer. 0.95. What is the ratio of the % of GDP of El Salvador in 2000 to that in 2001?
Provide a short and direct response. 1.02. What is the ratio of the % of GDP in Maldives in 2000 to that in 2001?
Your answer should be compact. 1.33. What is the ratio of the % of GDP in Central African Republic in 2000 to that in 2002?
Keep it short and to the point. 1.15. What is the ratio of the % of GDP of Ecuador in 2000 to that in 2002?
Your answer should be very brief. 0.9. What is the ratio of the % of GDP of El Salvador in 2000 to that in 2002?
Make the answer very short. 1.03. What is the ratio of the % of GDP of Maldives in 2000 to that in 2002?
Ensure brevity in your answer.  1.47. What is the ratio of the % of GDP in Central African Republic in 2000 to that in 2003?
Keep it short and to the point. 1.73. What is the ratio of the % of GDP of Ecuador in 2000 to that in 2003?
Keep it short and to the point. 1.09. What is the ratio of the % of GDP of Maldives in 2000 to that in 2003?
Offer a very short reply. 1.46. What is the ratio of the % of GDP in Central African Republic in 2000 to that in 2004?
Provide a short and direct response. 1.63. What is the ratio of the % of GDP of Ecuador in 2000 to that in 2004?
Make the answer very short. 1.05. What is the ratio of the % of GDP in El Salvador in 2000 to that in 2004?
Give a very brief answer. 1.04. What is the ratio of the % of GDP in Maldives in 2000 to that in 2004?
Provide a succinct answer. 1.16. What is the ratio of the % of GDP in Central African Republic in 2000 to that in 2005?
Make the answer very short. 1.13. What is the ratio of the % of GDP in Ecuador in 2000 to that in 2005?
Provide a succinct answer. 0.98. What is the ratio of the % of GDP of El Salvador in 2000 to that in 2005?
Ensure brevity in your answer.  1.05. What is the ratio of the % of GDP of Maldives in 2000 to that in 2005?
Your answer should be compact. 0.73. What is the ratio of the % of GDP in Central African Republic in 2001 to that in 2002?
Keep it short and to the point. 1.06. What is the ratio of the % of GDP of Ecuador in 2001 to that in 2002?
Give a very brief answer. 0.94. What is the ratio of the % of GDP of El Salvador in 2001 to that in 2002?
Make the answer very short. 1.02. What is the ratio of the % of GDP in Maldives in 2001 to that in 2002?
Keep it short and to the point. 1.11. What is the ratio of the % of GDP in Central African Republic in 2001 to that in 2003?
Ensure brevity in your answer.  1.6. What is the ratio of the % of GDP in Ecuador in 2001 to that in 2003?
Make the answer very short. 1.14. What is the ratio of the % of GDP of El Salvador in 2001 to that in 2003?
Your answer should be very brief. 0.98. What is the ratio of the % of GDP of Maldives in 2001 to that in 2003?
Your answer should be very brief. 1.1. What is the ratio of the % of GDP in Central African Republic in 2001 to that in 2004?
Provide a short and direct response. 1.5. What is the ratio of the % of GDP in Ecuador in 2001 to that in 2004?
Your response must be concise. 1.11. What is the ratio of the % of GDP of El Salvador in 2001 to that in 2004?
Offer a terse response. 1.03. What is the ratio of the % of GDP of Maldives in 2001 to that in 2004?
Your response must be concise. 0.88. What is the ratio of the % of GDP in Central African Republic in 2001 to that in 2005?
Provide a short and direct response. 1.05. What is the ratio of the % of GDP in Ecuador in 2001 to that in 2005?
Offer a very short reply. 1.03. What is the ratio of the % of GDP of El Salvador in 2001 to that in 2005?
Provide a short and direct response. 1.04. What is the ratio of the % of GDP in Maldives in 2001 to that in 2005?
Give a very brief answer. 0.55. What is the ratio of the % of GDP of Central African Republic in 2002 to that in 2003?
Provide a succinct answer. 1.5. What is the ratio of the % of GDP in Ecuador in 2002 to that in 2003?
Give a very brief answer. 1.21. What is the ratio of the % of GDP of Maldives in 2002 to that in 2003?
Provide a short and direct response. 1. What is the ratio of the % of GDP in Central African Republic in 2002 to that in 2004?
Make the answer very short. 1.41. What is the ratio of the % of GDP of Ecuador in 2002 to that in 2004?
Make the answer very short. 1.17. What is the ratio of the % of GDP in El Salvador in 2002 to that in 2004?
Offer a very short reply. 1.01. What is the ratio of the % of GDP in Maldives in 2002 to that in 2004?
Your response must be concise. 0.79. What is the ratio of the % of GDP of Central African Republic in 2002 to that in 2005?
Ensure brevity in your answer.  0.99. What is the ratio of the % of GDP of Ecuador in 2002 to that in 2005?
Make the answer very short. 1.1. What is the ratio of the % of GDP of El Salvador in 2002 to that in 2005?
Your answer should be compact. 1.02. What is the ratio of the % of GDP of Maldives in 2002 to that in 2005?
Give a very brief answer. 0.5. What is the ratio of the % of GDP in Central African Republic in 2003 to that in 2004?
Provide a succinct answer. 0.94. What is the ratio of the % of GDP in Ecuador in 2003 to that in 2004?
Provide a short and direct response. 0.97. What is the ratio of the % of GDP in El Salvador in 2003 to that in 2004?
Keep it short and to the point. 1.05. What is the ratio of the % of GDP of Maldives in 2003 to that in 2004?
Your answer should be very brief. 0.8. What is the ratio of the % of GDP of Central African Republic in 2003 to that in 2005?
Provide a succinct answer. 0.66. What is the ratio of the % of GDP in Ecuador in 2003 to that in 2005?
Provide a succinct answer. 0.91. What is the ratio of the % of GDP of El Salvador in 2003 to that in 2005?
Your answer should be compact. 1.06. What is the ratio of the % of GDP in Maldives in 2003 to that in 2005?
Offer a very short reply. 0.5. What is the ratio of the % of GDP of Central African Republic in 2004 to that in 2005?
Provide a short and direct response. 0.7. What is the ratio of the % of GDP in Ecuador in 2004 to that in 2005?
Keep it short and to the point. 0.93. What is the ratio of the % of GDP in El Salvador in 2004 to that in 2005?
Your answer should be very brief. 1.01. What is the ratio of the % of GDP in Maldives in 2004 to that in 2005?
Give a very brief answer. 0.63. What is the difference between the highest and the second highest % of GDP in Central African Republic?
Keep it short and to the point. 1.89. What is the difference between the highest and the second highest % of GDP in Ecuador?
Offer a very short reply. 1.35. What is the difference between the highest and the second highest % of GDP of El Salvador?
Give a very brief answer. 0.06. What is the difference between the highest and the second highest % of GDP in Maldives?
Your answer should be very brief. 2.18. What is the difference between the highest and the lowest % of GDP of Central African Republic?
Provide a short and direct response. 6.56. What is the difference between the highest and the lowest % of GDP in Ecuador?
Ensure brevity in your answer.  4.11. What is the difference between the highest and the lowest % of GDP of El Salvador?
Your response must be concise. 0.9. What is the difference between the highest and the lowest % of GDP of Maldives?
Give a very brief answer. 17.86. 